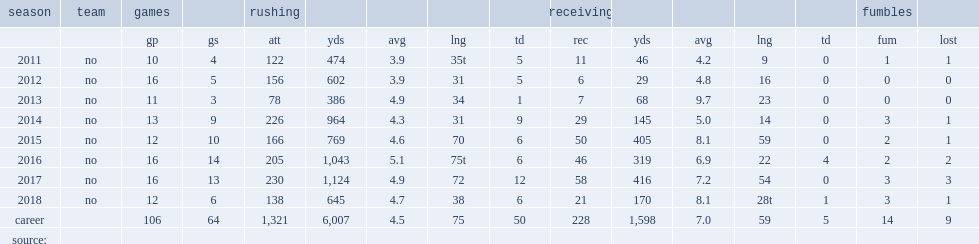How many rushing yards did mark ingram jr. get in 2014? 964.0. 